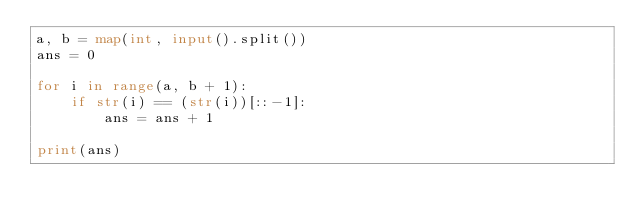Convert code to text. <code><loc_0><loc_0><loc_500><loc_500><_Python_>a, b = map(int, input().split())
ans = 0

for i in range(a, b + 1):
    if str(i) == (str(i))[::-1]:
        ans = ans + 1

print(ans)</code> 